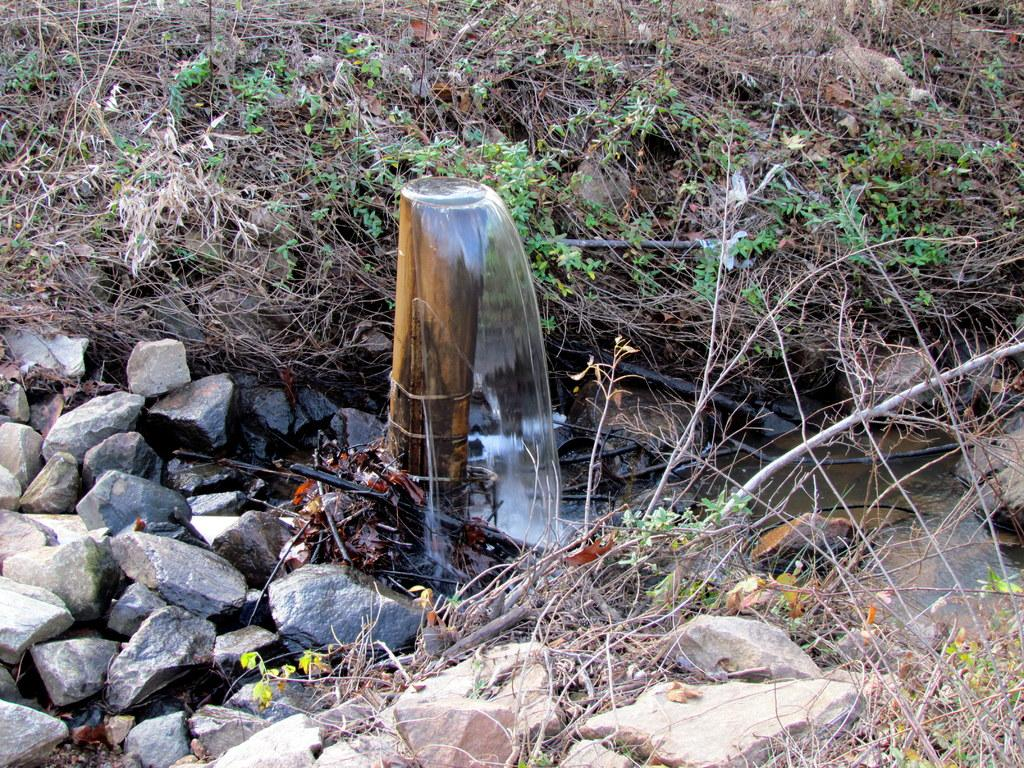What is the main feature in the center of the image? There is a fountain in the center of the image. What can be found at the bottom of the image? There are rocks at the bottom of the image. What type of natural materials are visible in the image? Twigs are visible in the image. What type of vegetation can be seen in the background of the image? There are plants in the background of the image. What type of picture is hanging on the wall in the image? There is no wall or picture hanging on it in the image; it features a fountain, rocks, twigs, and plants. What type of teeth can be seen in the image? There are no teeth visible in the image. 